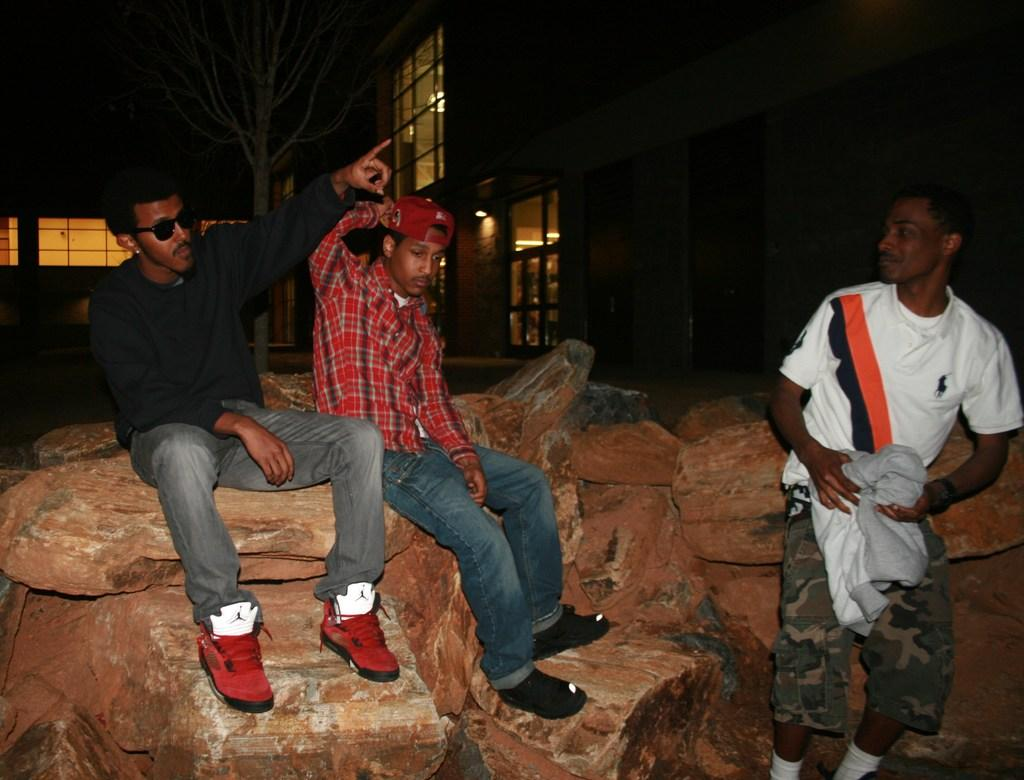What are the people in the image doing? The people in the image are sitting on stones. What can be seen in the background of the image? There is a building in the background of the image. What type of toy is being used by the people in the image? There is no toy present in the image; the people are sitting on stones. 